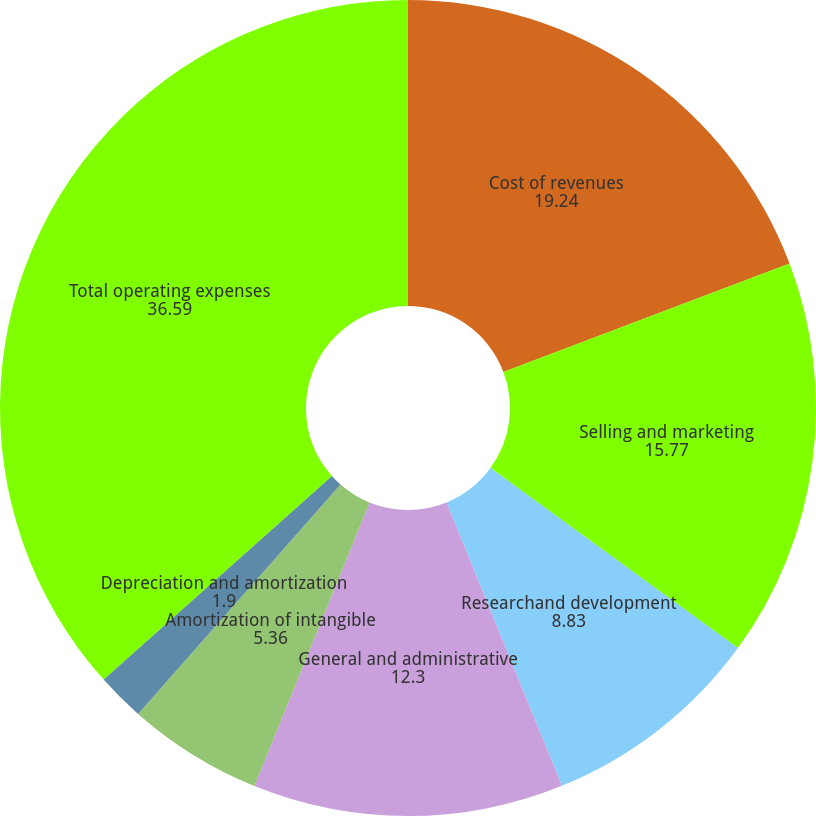Convert chart. <chart><loc_0><loc_0><loc_500><loc_500><pie_chart><fcel>Cost of revenues<fcel>Selling and marketing<fcel>Researchand development<fcel>General and administrative<fcel>Amortization of intangible<fcel>Depreciation and amortization<fcel>Total operating expenses<nl><fcel>19.24%<fcel>15.77%<fcel>8.83%<fcel>12.3%<fcel>5.36%<fcel>1.9%<fcel>36.59%<nl></chart> 